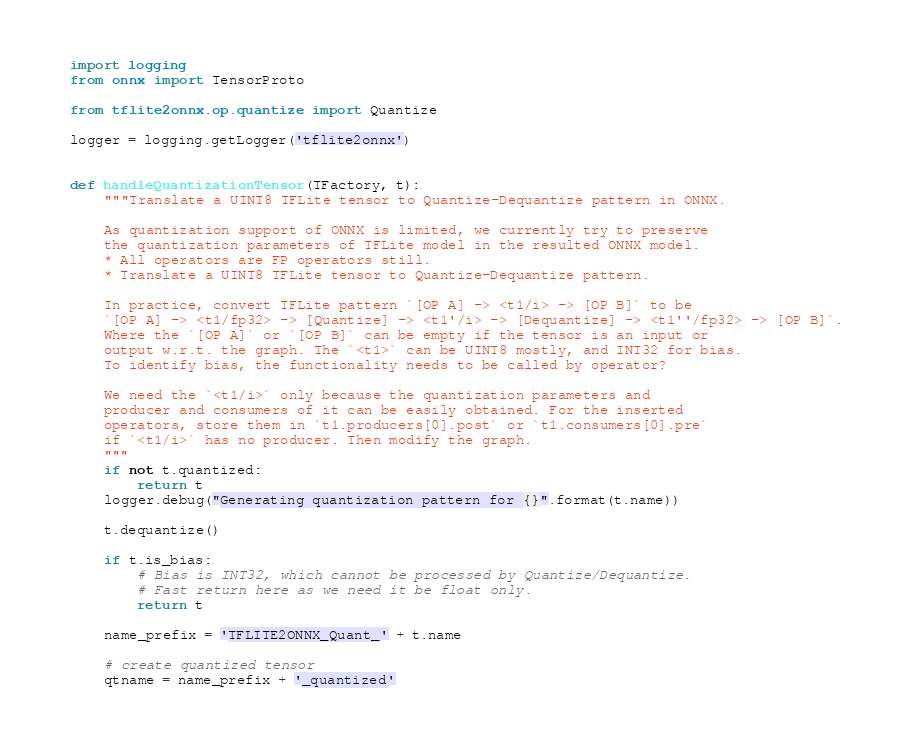<code> <loc_0><loc_0><loc_500><loc_500><_Python_>import logging
from onnx import TensorProto

from tflite2onnx.op.quantize import Quantize

logger = logging.getLogger('tflite2onnx')


def handleQuantizationTensor(TFactory, t):
    """Translate a UINT8 TFLite tensor to Quantize-Dequantize pattern in ONNX.

    As quantization support of ONNX is limited, we currently try to preserve
    the quantization parameters of TFLite model in the resulted ONNX model.
    * All operators are FP operators still.
    * Translate a UINT8 TFLite tensor to Quantize-Dequantize pattern.

    In practice, convert TFLite pattern `[OP A] -> <t1/i> -> [OP B]` to be
    `[OP A] -> <t1/fp32> -> [Quantize] -> <t1'/i> -> [Dequantize] -> <t1''/fp32> -> [OP B]`.
    Where the `[OP A]` or `[OP B]` can be empty if the tensor is an input or
    output w.r.t. the graph. The `<t1>` can be UINT8 mostly, and INT32 for bias.
    To identify bias, the functionality needs to be called by operator?

    We need the `<t1/i>` only because the quantization parameters and
    producer and consumers of it can be easily obtained. For the inserted
    operators, store them in `t1.producers[0].post` or `t1.consumers[0].pre`
    if `<t1/i>` has no producer. Then modify the graph.
    """
    if not t.quantized:
        return t
    logger.debug("Generating quantization pattern for {}".format(t.name))

    t.dequantize()

    if t.is_bias:
        # Bias is INT32, which cannot be processed by Quantize/Dequantize.
        # Fast return here as we need it be float only.
        return t

    name_prefix = 'TFLITE2ONNX_Quant_' + t.name

    # create quantized tensor
    qtname = name_prefix + '_quantized'</code> 